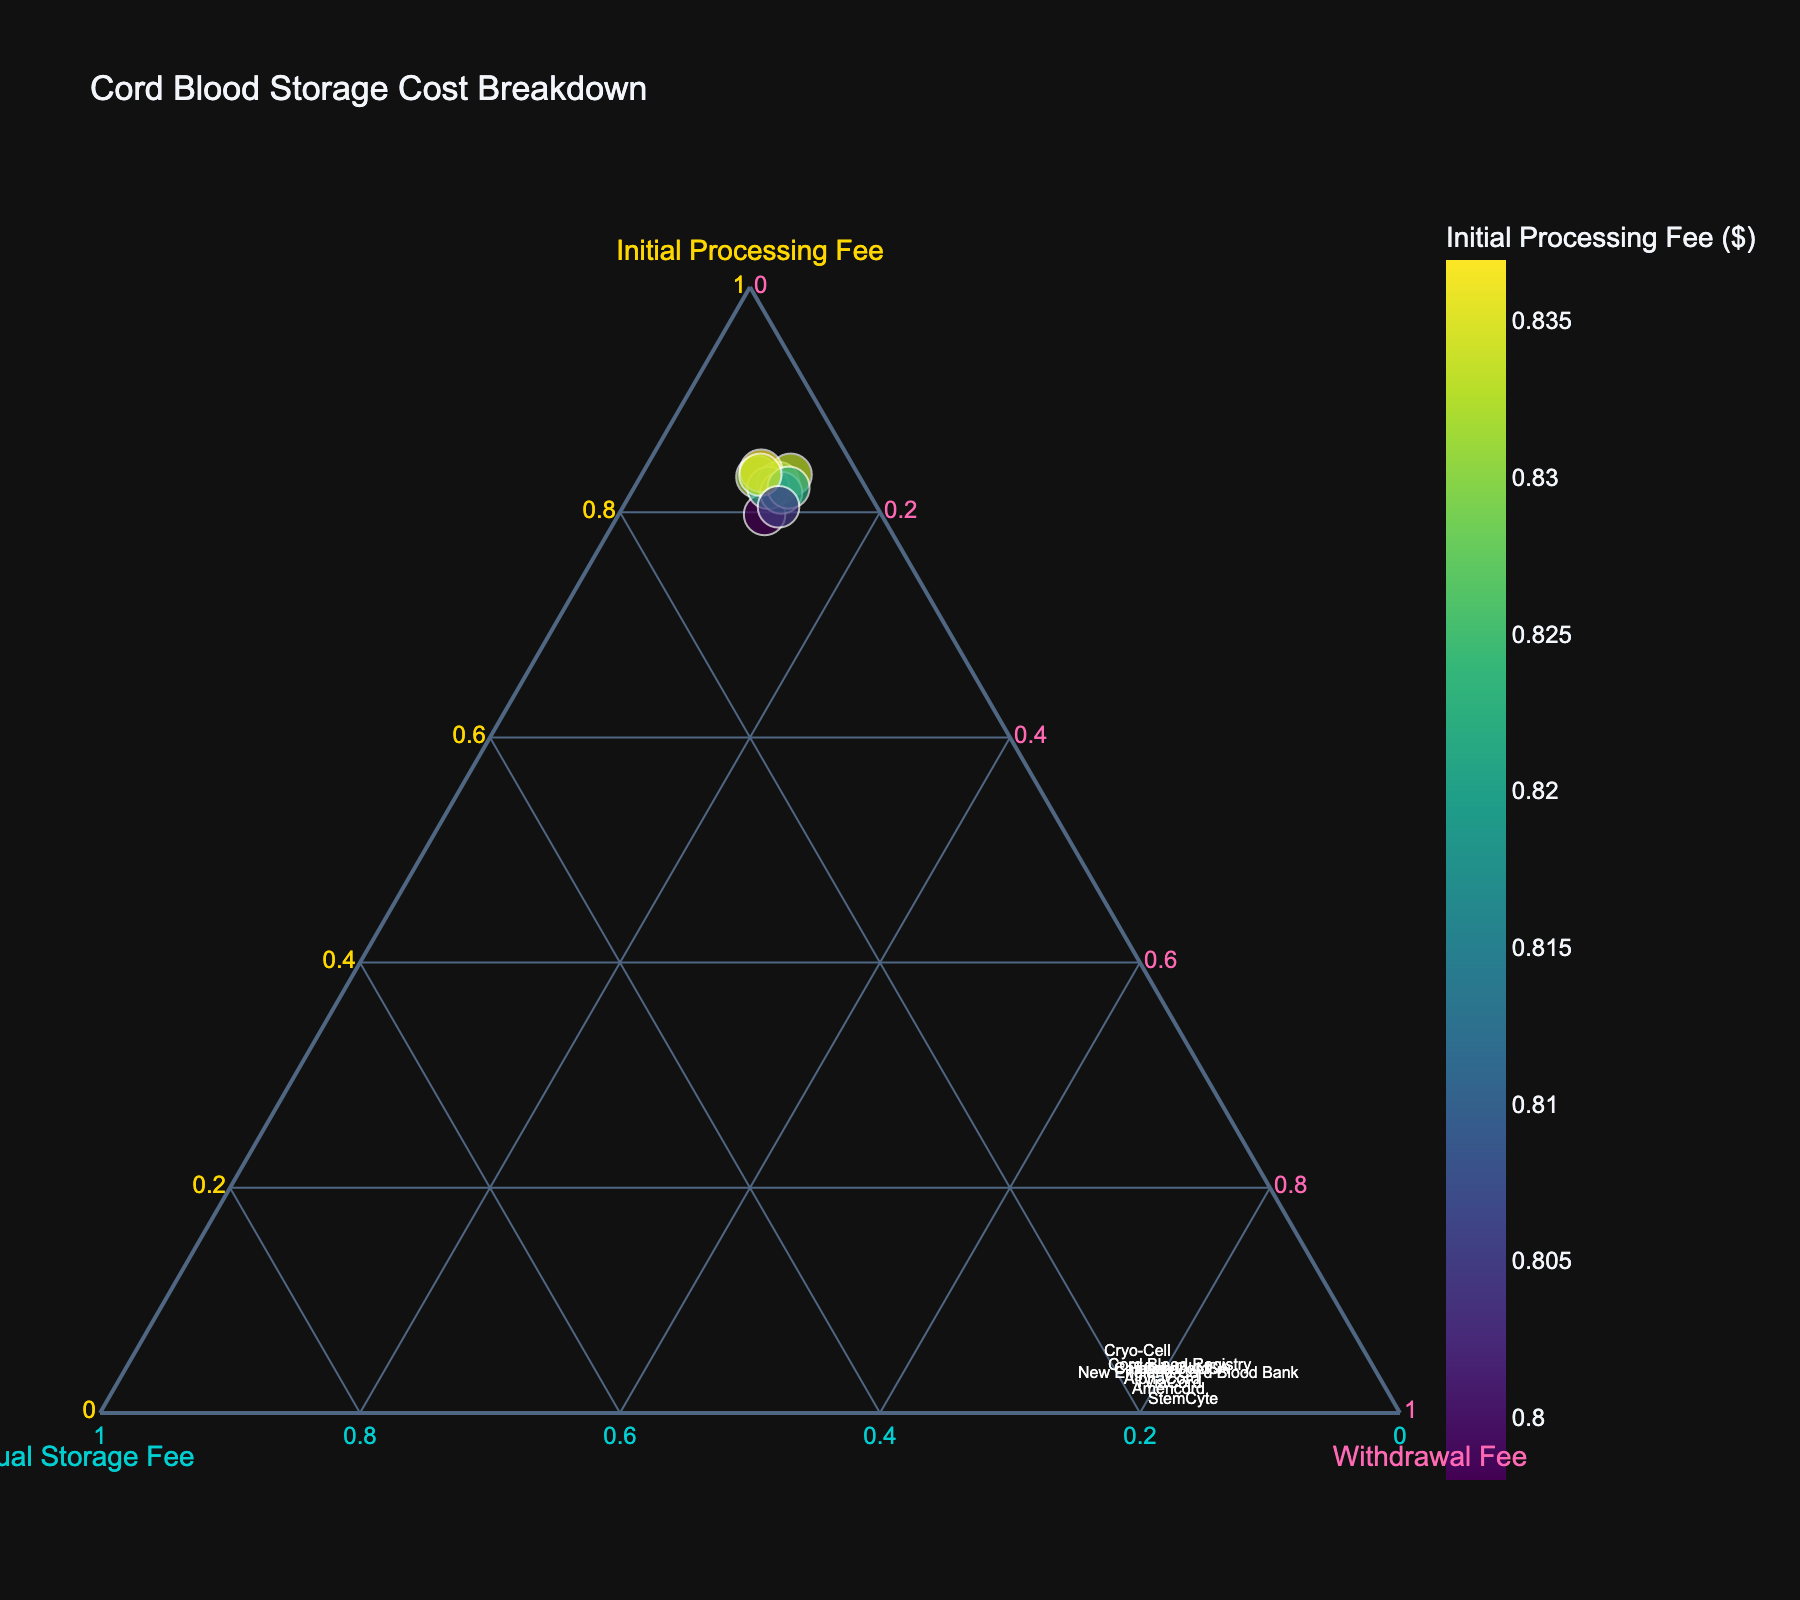What is the title of the figure? The title of the figure should be clearly displayed at the top of the image. In this case, it will reflect the main subject of the plot.
Answer: Cord Blood Storage Cost Breakdown Which company has the highest Initial Processing Fee? To identify which company has the highest Initial Processing Fee, locate the data point that is closest to the axis labeled 'Initial Processing Fee'.
Answer: LifebankUSA How many companies are included in this figure? Count the number of unique data points (each representing a company) in the figure, since each company will have a single representation on the plot.
Answer: 10 Which companies have an Initial Processing Fee greater than $1900? Look for points in the figure that are positioned close to the Initial Processing Fee side and filter out the companies by their exact fees.
Answer: StemCyte, New England Cord Blood Bank, LifebankUSA On average, how much higher is the Annual Storage Fee compared to the Withdrawal Fee among the companies? Calculate the Annual Storage Fee and Withdrawal Fee differences for each company, sum these differences, and then divide by the number of companies to find the average.
Answer: $0 Which company is positioned closest to the center of the plot (indicating similar proportions of Initial Processing Fee, Annual Storage Fee, and Withdrawal Fee)? Identify the data point that is equidistant from all three axes using visual approximation.
Answer: CariCord How does Cord Blood Registry compare in terms of the Withdrawal Fee to StemCyte? Locate both companies on the plot and compare their placement relative to the Withdrawal Fee axis to determine which has the higher value.
Answer: StemCyte has a higher Withdrawal Fee Which company has the lowest Annual Storage Fee? Identify the data point closest to the axis labeled 'Annual Storage Fee' and check the company name associated with it.
Answer: StemCyte Compare FamilyCord's Initial Processing Fee and Annual Storage Fee to Americord's. Which is higher in each category? Find the data points for FamilyCord and Americord and compare their distances from the 'Initial Processing Fee' and 'Annual Storage Fee' axes, respectively.
Answer: FamilyCord has a higher Initial Processing Fee, whereas Americord has a lower Annual Storage Fee What is the relative proportion of the Initial Processing Fee for AlphaCord compared to its Annual Storage Fee? On the ternary plot, compare the distance of AlphaCord's point from the 'Initial Processing Fee' and 'Annual Storage Fee' axes to gauge their relative proportions.
Answer: The Initial Processing Fee is higher 